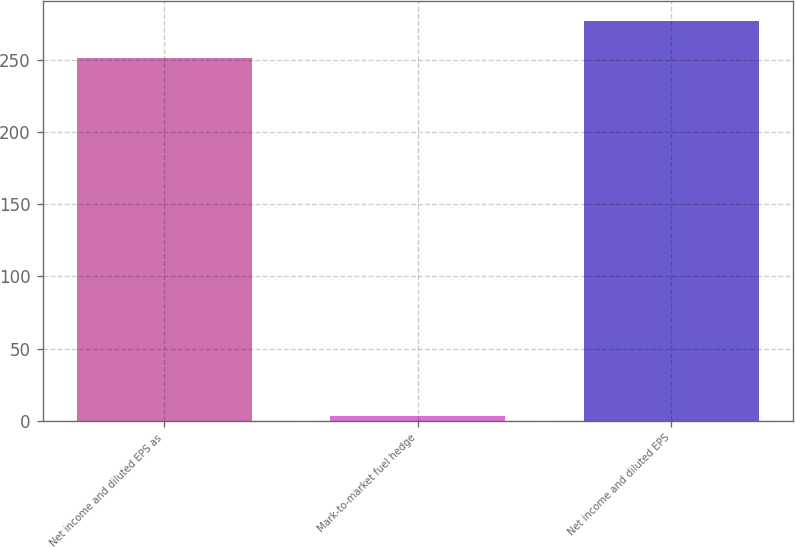<chart> <loc_0><loc_0><loc_500><loc_500><bar_chart><fcel>Net income and diluted EPS as<fcel>Mark-to-market fuel hedge<fcel>Net income and diluted EPS<nl><fcel>251.1<fcel>3.3<fcel>277.03<nl></chart> 